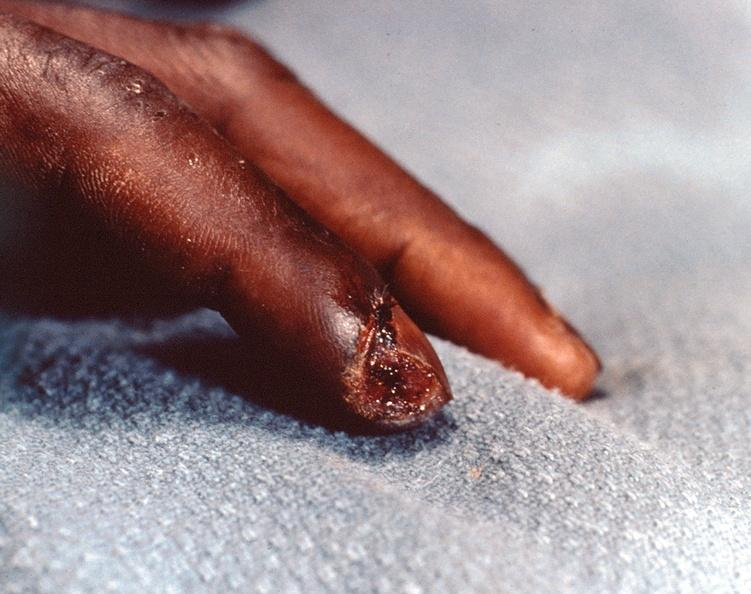does nipple duplication show necrosis of distal finger in a patient with panniculitis and fascitis?
Answer the question using a single word or phrase. No 